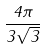<formula> <loc_0><loc_0><loc_500><loc_500>\frac { 4 \pi } { 3 \sqrt { 3 } }</formula> 